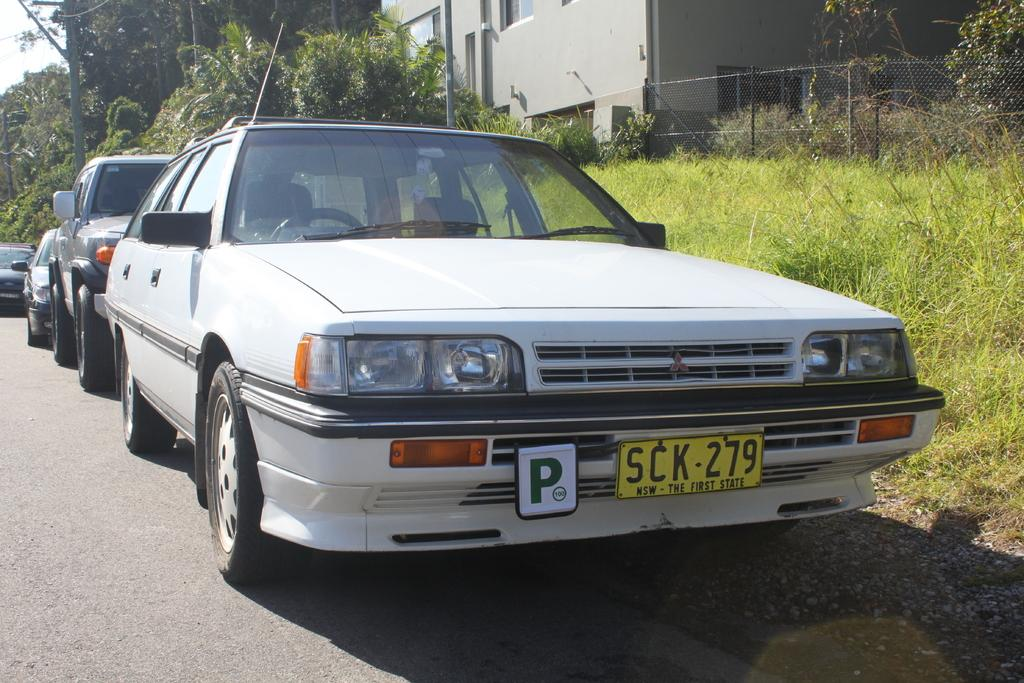What can be seen parked in the image? There are vehicles parked in the image. What structures are present in the image? There are poles, a net fence, and a building in the image. What type of vegetation is visible in the image? There is grass and trees in the image. What is visible in the background of the image? The sky is visible in the background of the image. What type of seed is being distributed in the image? There is no seed or distribution process present in the image. What type of arch can be seen in the image? There is no arch present in the image. 